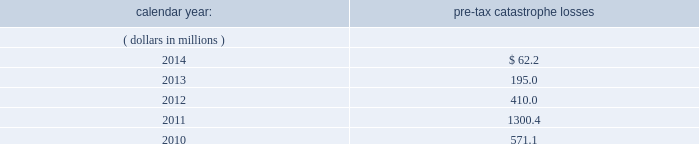Available information .
The company 2019s annual reports on form 10-k , quarterly reports on form 10-q , current reports on form 8- k , proxy statements and amendments to those reports are available free of charge through the company 2019s internet website at http://www.everestregroup.com as soon as reasonably practicable after such reports are electronically filed with the securities and exchange commission ( the 201csec 201d ) .
Item 1a .
Risk factors in addition to the other information provided in this report , the following risk factors should be considered when evaluating an investment in our securities .
If the circumstances contemplated by the individual risk factors materialize , our business , financial condition and results of operations could be materially and adversely affected and the trading price of our common shares could decline significantly .
Risks relating to our business fluctuations in the financial markets could result in investment losses .
Prolonged and severe disruptions in the overall public debt and equity markets , such as occurred during 2008 , could result in significant realized and unrealized losses in our investment portfolio .
Although financial markets have significantly improved since 2008 , they could deteriorate in the future .
There could also be disruption in individual market sectors , such as occurred in the energy sector during the fourth quarter of 2014 .
Such declines in the financial markets could result in significant realized and unrealized losses on investments and could have a material adverse impact on our results of operations , equity , business and insurer financial strength and debt ratings .
Our results could be adversely affected by catastrophic events .
We are exposed to unpredictable catastrophic events , including weather-related and other natural catastrophes , as well as acts of terrorism .
Any material reduction in our operating results caused by the occurrence of one or more catastrophes could inhibit our ability to pay dividends or to meet our interest and principal payment obligations .
Subsequent to april 1 , 2010 , we define a catastrophe as an event that causes a loss on property exposures before reinsurance of at least $ 10.0 million , before corporate level reinsurance and taxes .
Prior to april 1 , 2010 , we used a threshold of $ 5.0 million .
By way of illustration , during the past five calendar years , pre-tax catastrophe losses , net of contract specific reinsurance but before cessions under corporate reinsurance programs , were as follows: .
Our losses from future catastrophic events could exceed our projections .
We use projections of possible losses from future catastrophic events of varying types and magnitudes as a strategic underwriting tool .
We use these loss projections to estimate our potential catastrophe losses in certain geographic areas and decide on the placement of retrocessional coverage or other actions to limit the extent of potential losses in a given geographic area .
These loss projections are approximations , reliant on a mix of quantitative and qualitative processes , and actual losses may exceed the projections by a material amount , resulting in a material adverse effect on our financial condition and results of operations. .
What was the ratio of the pre-tax catastrophe losses from 2014 to 2013? 
Rationale: for every dollar of pre-tax catastrophe losses in 2013 there was 0.32 in 2014
Computations: (62.2 - 195.0)
Answer: -132.8. 